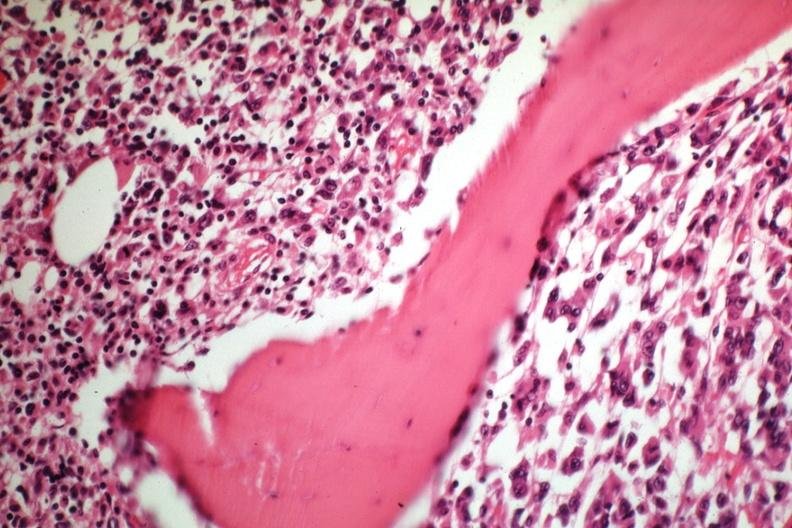s malignant adenoma slide?
Answer the question using a single word or phrase. No 